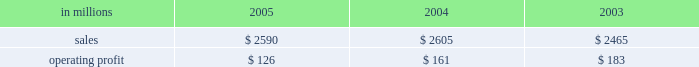Entering 2006 , industrial packaging earnings are expected to improve significantly in the first quarter compared with the fourth quarter 2005 .
Average price realizations should continue to benefit from price in- creases announced in late 2005 and early 2006 for linerboard and domestic boxes .
Containerboard sales volumes are expected to drop slightly in the 2006 first quarter due to fewer shipping days , but growth is antici- pated for u.s .
Converted products due to stronger de- mand .
Costs for wood , freight and energy are expected to remain stable during the 2006 first quarter , approach- ing fourth quarter 2005 levels .
The continued im- plementation of the new supply chain model at our mills during 2006 will bring additional efficiency improve- ments and cost savings .
On a global basis , the european container operating results are expected to improve as a result of targeted market growth and cost reduction ini- tiatives , and we will begin seeing further contributions from our recent moroccan box plant acquisition and from international paper distribution limited .
Consumer packaging demand and pricing for consumer packaging prod- ucts correlate closely with consumer spending and gen- eral economic activity .
In addition to prices and volumes , major factors affecting the profitability of con- sumer packaging are raw material and energy costs , manufacturing efficiency and product mix .
Consumer packaging 2019s 2005 net sales of $ 2.6 bil- lion were flat compared with 2004 and 5% ( 5 % ) higher com- pared with 2003 .
Operating profits in 2005 declined 22% ( 22 % ) from 2004 and 31% ( 31 % ) from 2003 as improved price realizations ( $ 46 million ) and favorable operations in the mills and converting operations ( $ 60 million ) could not overcome the impact of cost increases in energy , wood , polyethylene and other raw materials ( $ 120 million ) , lack-of-order downtime ( $ 13 million ) and other costs ( $ 8 million ) .
Consumer packaging in millions 2005 2004 2003 .
Bleached board net sales of $ 864 million in 2005 were up from $ 842 million in 2004 and $ 751 million in 2003 .
The effects in 2005 of improved average price realizations and mill operating improvements were not enough to offset increased energy , wood , polyethylene and other raw material costs , a slight decrease in volume and increased lack-of-order downtime .
Bleached board mills took 100000 tons of downtime in 2005 , including 65000 tons of lack-of-order downtime , compared with 40000 tons of downtime in 2004 , none of which was market related .
During 2005 , restructuring and manufacturing improvement plans were implemented to reduce costs and improve market alignment .
Foodservice net sales were $ 437 million in 2005 compared with $ 480 million in 2004 and $ 460 million in 2003 .
Average sales prices in 2005 were up 3% ( 3 % ) ; how- ever , domestic cup and lid sales volumes were 5% ( 5 % ) lower than in 2004 as a result of a rationalization of our cus- tomer base early in 2005 .
Operating profits in 2005 in- creased 147% ( 147 % ) compared with 2004 , largely due to the settlement of a lawsuit and a favorable adjustment on the sale of the jackson , tennessee bag plant .
Excluding unusual items , operating profits were flat as improved price realizations offset increased costs for bleached board and resin .
Shorewood net sales of $ 691 million in 2005 were essentially flat with net sales in 2004 of $ 687 million , but were up compared with $ 665 million in 2003 .
Operating profits in 2005 were 17% ( 17 % ) above 2004 levels and about equal to 2003 levels .
Improved margins resulting from a rationalization of the customer mix and the effects of improved manufacturing operations , including the successful start up of our south korean tobacco operations , more than offset cost increases for board and paper and the impact of unfavorable foreign exchange rates in canada .
Beverage packaging net sales were $ 597 million in 2005 , $ 595 million in 2004 and $ 589 million in 2003 .
Average sale price realizations increased 2% ( 2 % ) compared with 2004 , principally the result of the pass-through of higher raw material costs , although the implementation of price increases continues to be impacted by com- petitive pressures .
Operating profits were down 14% ( 14 % ) compared with 2004 and 19% ( 19 % ) compared with 2003 , due principally to increases in board and resin costs .
In 2006 , the bleached board market is expected to remain strong , with sales volumes increasing in the first quarter compared with the fourth quarter of 2005 for both folding carton and cup products .
Improved price realizations are also expected for bleached board and in our foodservice and beverage packaging businesses , al- though continued high costs for energy , wood and resin will continue to negatively impact earnings .
Shorewood should continue to benefit from strong asian operations and from targeted sales volume growth in 2006 .
Capital improvements and operational excellence initiatives undertaken in 2005 should benefit operating results in 2006 for all businesses .
Distribution our distribution business , principally represented by our xpedx business , markets a diverse array of products and supply chain services to customers in many business segments .
Customer demand is generally sensitive to changes in general economic conditions , although the .
Was percentage of consumer packaging sales was due to foodservice net sales in 2004? 
Computations: (480 / 2605)
Answer: 0.18426. 